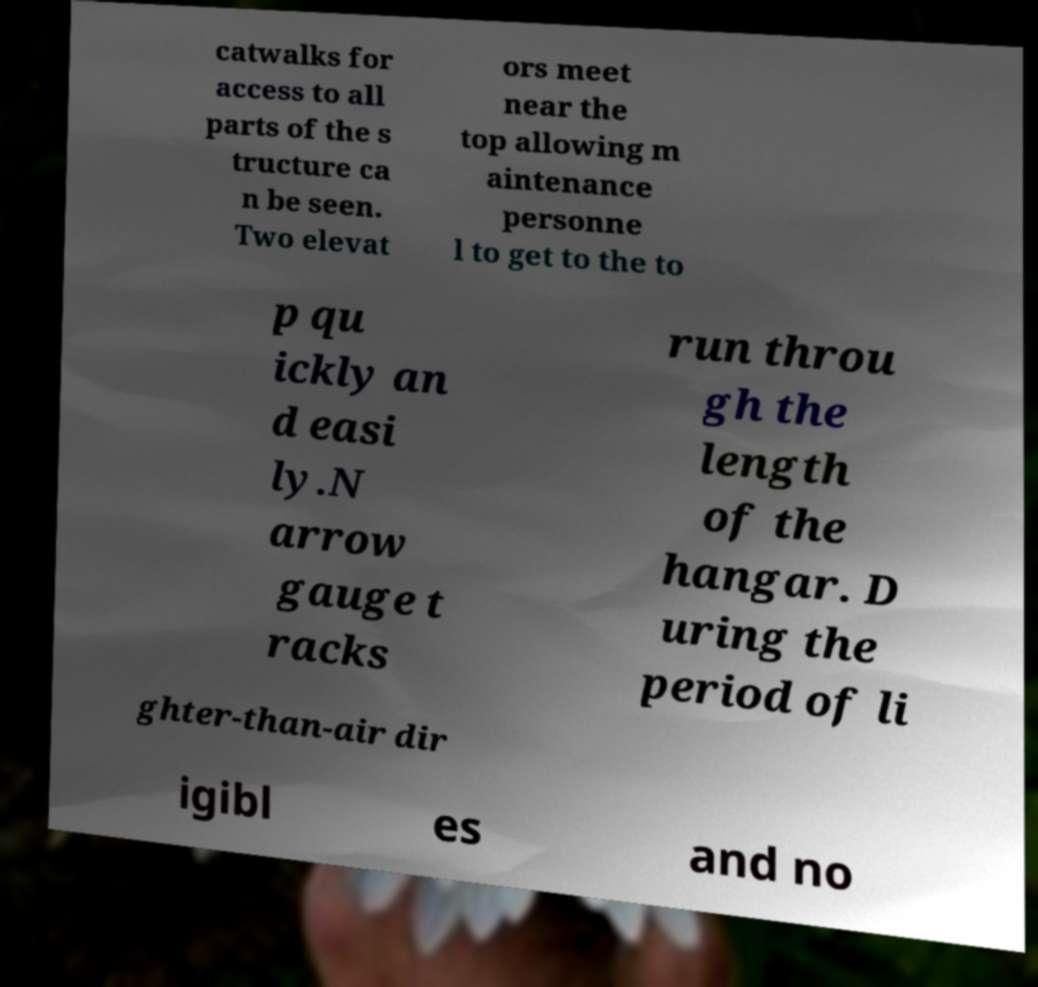For documentation purposes, I need the text within this image transcribed. Could you provide that? catwalks for access to all parts of the s tructure ca n be seen. Two elevat ors meet near the top allowing m aintenance personne l to get to the to p qu ickly an d easi ly.N arrow gauge t racks run throu gh the length of the hangar. D uring the period of li ghter-than-air dir igibl es and no 